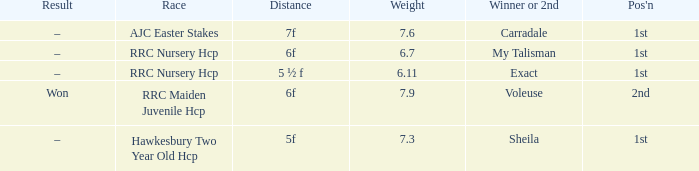What is the weight number when the distance was 5 ½ f? 1.0. 